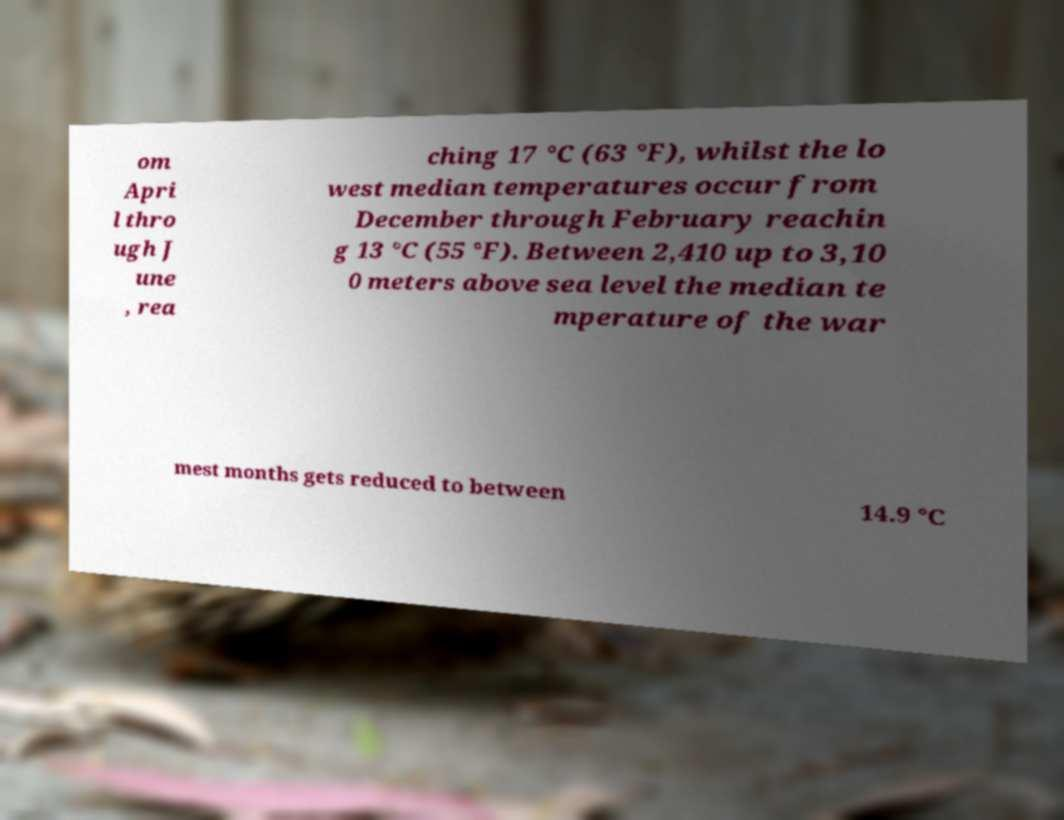Please identify and transcribe the text found in this image. om Apri l thro ugh J une , rea ching 17 °C (63 °F), whilst the lo west median temperatures occur from December through February reachin g 13 °C (55 °F). Between 2,410 up to 3,10 0 meters above sea level the median te mperature of the war mest months gets reduced to between 14.9 °C 